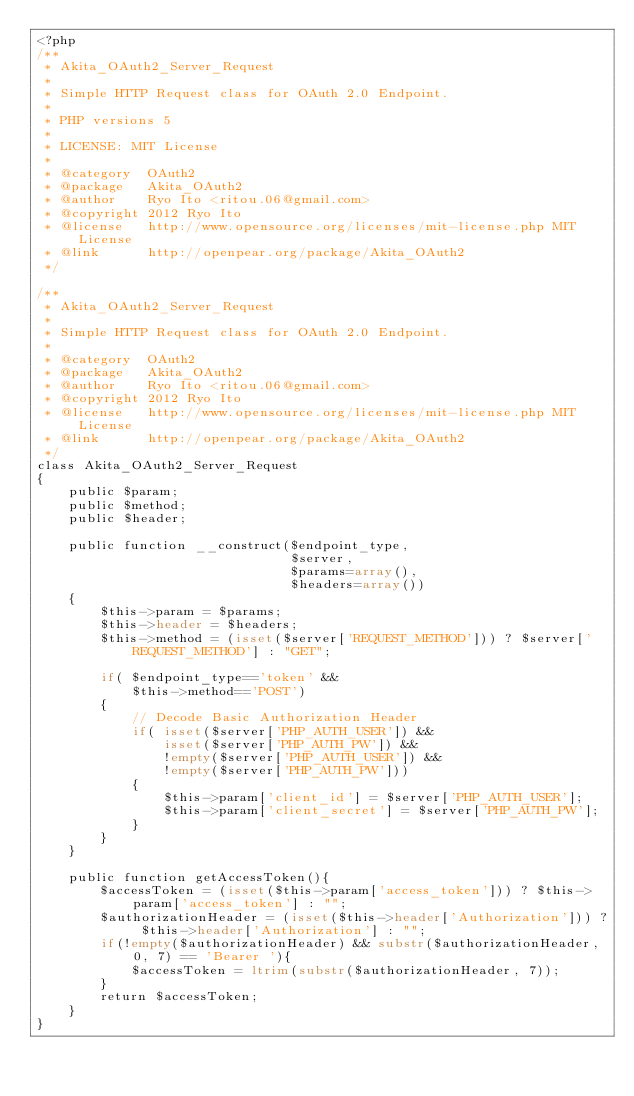<code> <loc_0><loc_0><loc_500><loc_500><_PHP_><?php
/**
 * Akita_OAuth2_Server_Request
 *
 * Simple HTTP Request class for OAuth 2.0 Endpoint.
 *
 * PHP versions 5
 *
 * LICENSE: MIT License
 *
 * @category  OAuth2
 * @package   Akita_OAuth2
 * @author    Ryo Ito <ritou.06@gmail.com>
 * @copyright 2012 Ryo Ito
 * @license   http://www.opensource.org/licenses/mit-license.php MIT License
 * @link      http://openpear.org/package/Akita_OAuth2
 */

/**
 * Akita_OAuth2_Server_Request
 *
 * Simple HTTP Request class for OAuth 2.0 Endpoint.
 *
 * @category  OAuth2
 * @package   Akita_OAuth2
 * @author    Ryo Ito <ritou.06@gmail.com>
 * @copyright 2012 Ryo Ito
 * @license   http://www.opensource.org/licenses/mit-license.php MIT License
 * @link      http://openpear.org/package/Akita_OAuth2
 */
class Akita_OAuth2_Server_Request
{
    public $param;
    public $method;
    public $header;

    public function __construct($endpoint_type,
                                $server, 
                                $params=array(),
                                $headers=array())
    {
        $this->param = $params;
        $this->header = $headers;
        $this->method = (isset($server['REQUEST_METHOD'])) ? $server['REQUEST_METHOD'] : "GET";

        if( $endpoint_type=='token' &&
            $this->method=='POST')
        {
            // Decode Basic Authorization Header
            if( isset($server['PHP_AUTH_USER']) &&
                isset($server['PHP_AUTH_PW']) &&
                !empty($server['PHP_AUTH_USER']) && 
                !empty($server['PHP_AUTH_PW']))
            {
                $this->param['client_id'] = $server['PHP_AUTH_USER'];
                $this->param['client_secret'] = $server['PHP_AUTH_PW'];
            }
        }
    }

    public function getAccessToken(){
        $accessToken = (isset($this->param['access_token'])) ? $this->param['access_token'] : "";
        $authorizationHeader = (isset($this->header['Authorization'])) ? $this->header['Authorization'] : "";
        if(!empty($authorizationHeader) && substr($authorizationHeader, 0, 7) == 'Bearer '){
            $accessToken = ltrim(substr($authorizationHeader, 7));
        }
        return $accessToken;
    }
}
</code> 